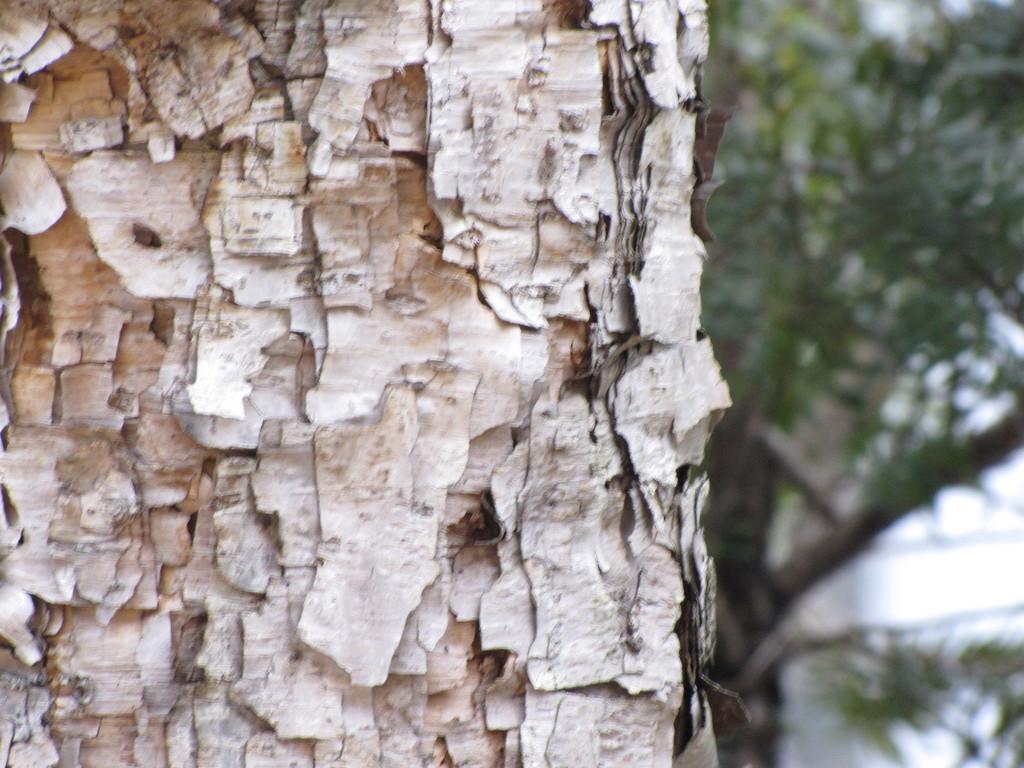Describe this image in one or two sentences. In the picture I can see trees. The background of the image is blurred. 